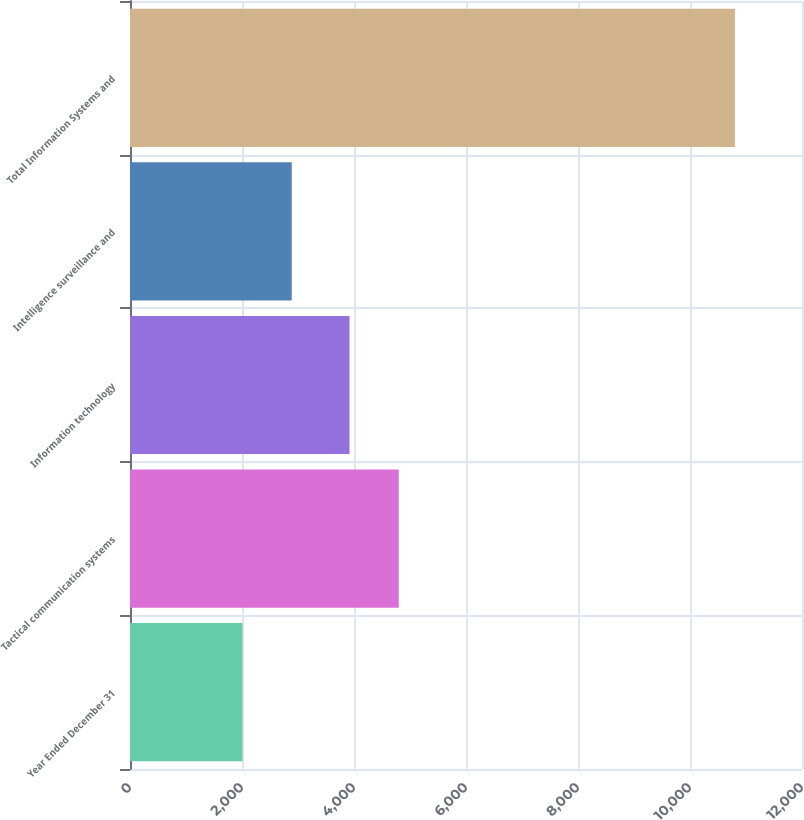Convert chart. <chart><loc_0><loc_0><loc_500><loc_500><bar_chart><fcel>Year Ended December 31<fcel>Tactical communication systems<fcel>Information technology<fcel>Intelligence surveillance and<fcel>Total Information Systems and<nl><fcel>2009<fcel>4799.3<fcel>3920<fcel>2888.3<fcel>10802<nl></chart> 